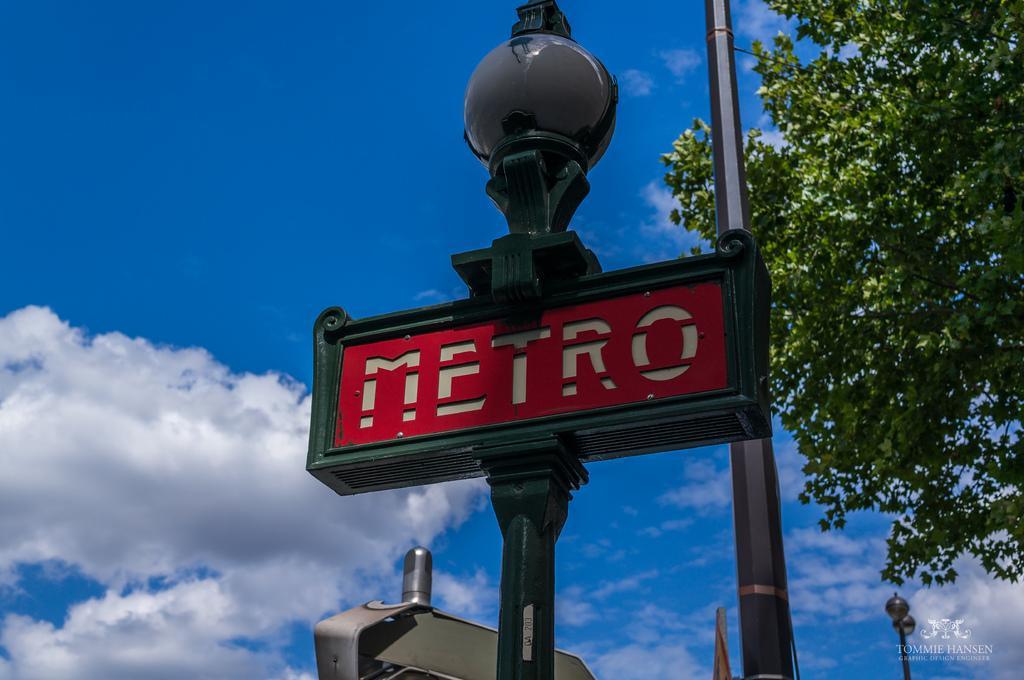Could you give a brief overview of what you see in this image? In this image we can see a signboard on a pole. In the background, we can see a group of poles, tree and the cloudy sky. 